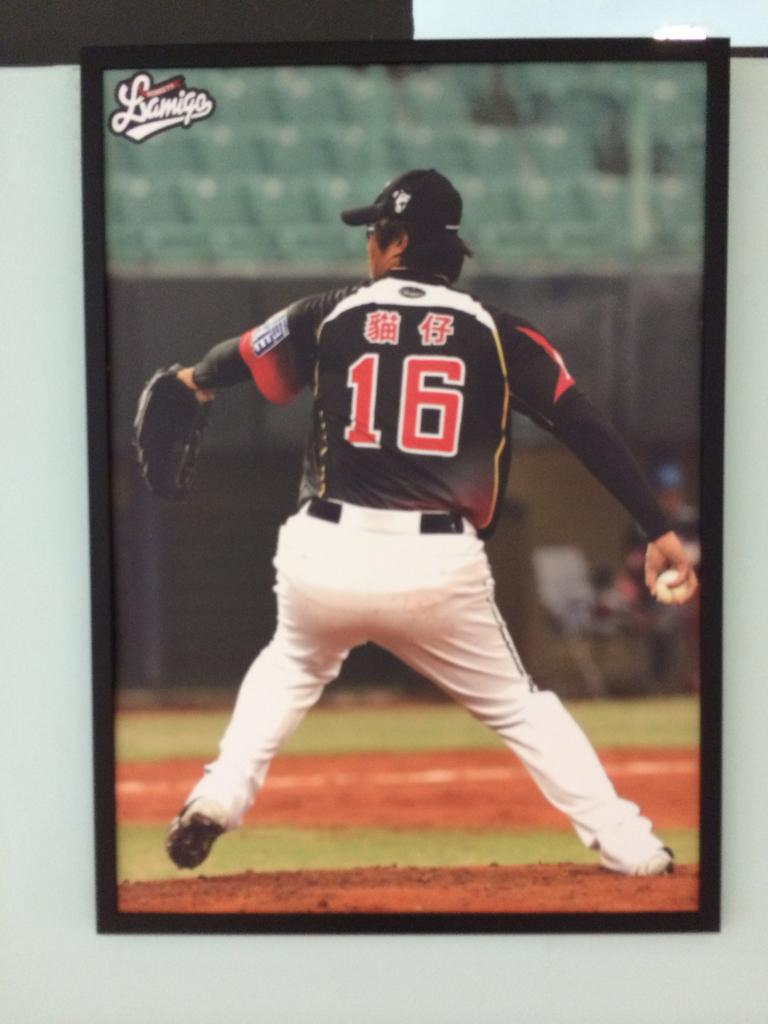<image>
Share a concise interpretation of the image provided. The baseball player is wearing a mostly black jersey with the number 16. 